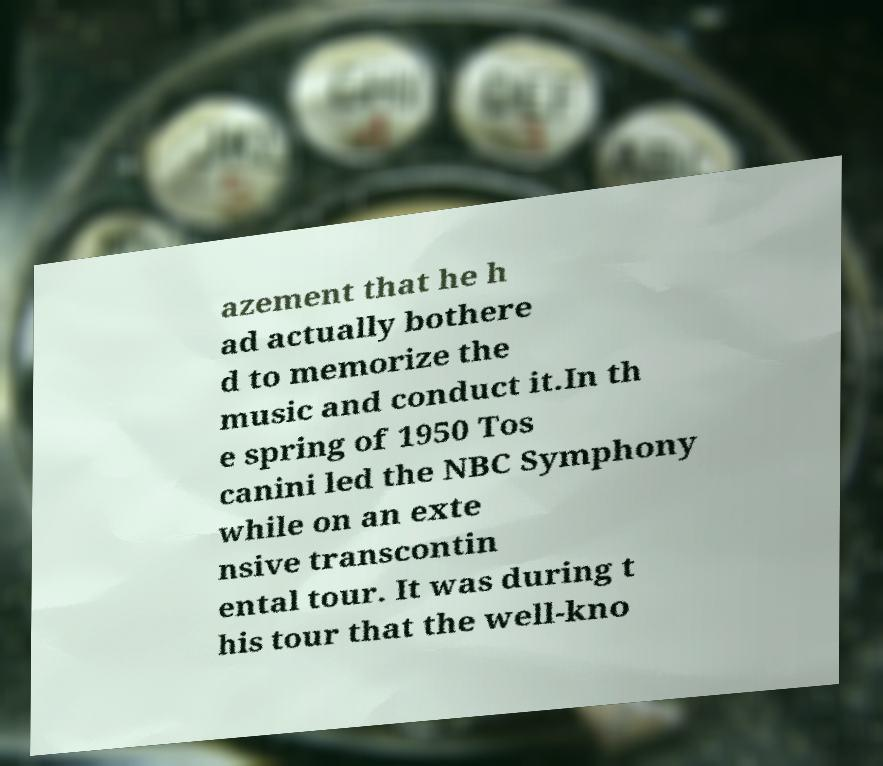I need the written content from this picture converted into text. Can you do that? azement that he h ad actually bothere d to memorize the music and conduct it.In th e spring of 1950 Tos canini led the NBC Symphony while on an exte nsive transcontin ental tour. It was during t his tour that the well-kno 